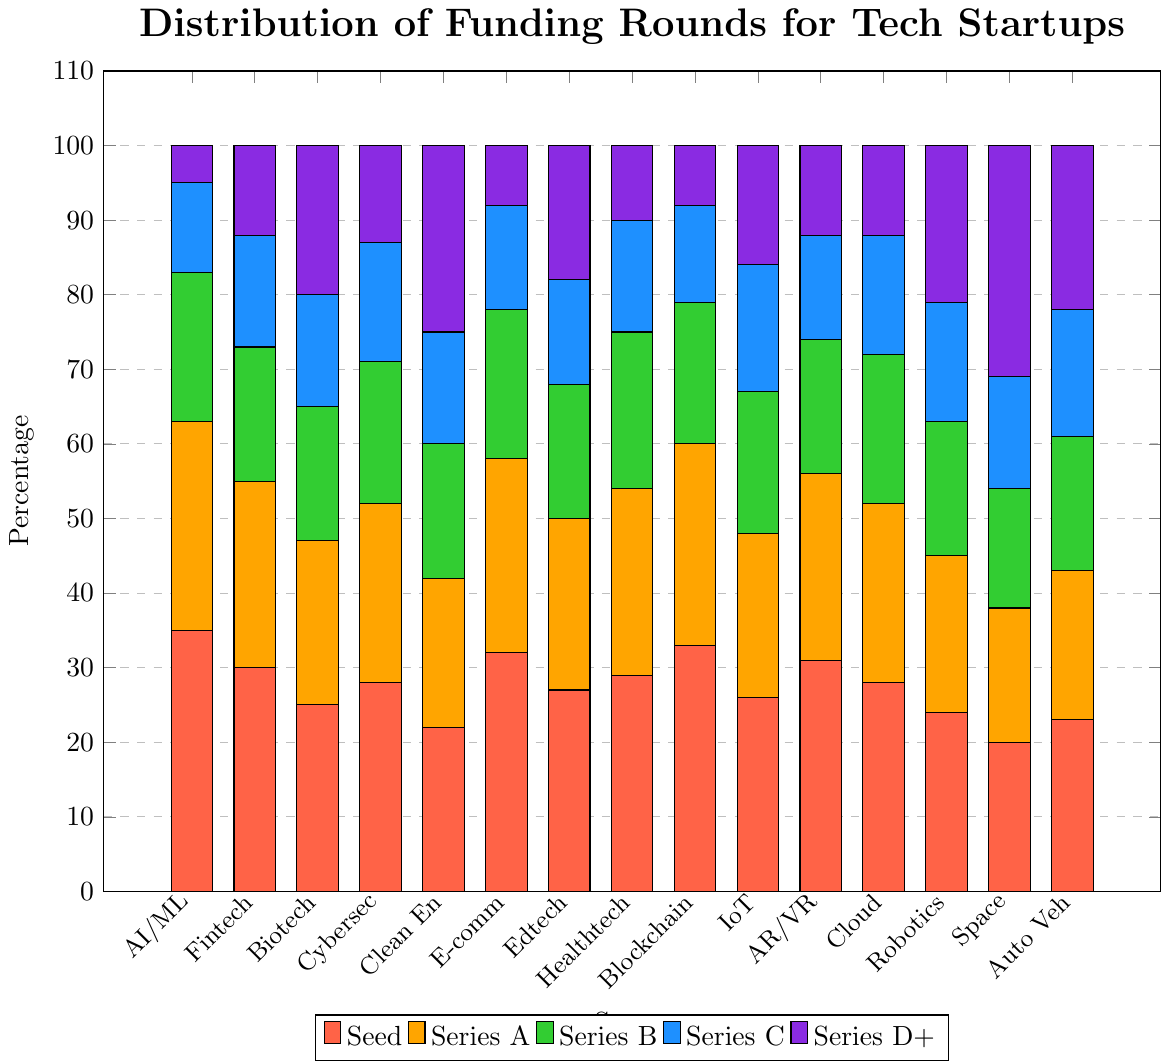Which sector has the highest number of Seed funding rounds? The highest number of Seed funding rounds is indicated by the tallest red bar. By comparing the red bars, AI/Machine Learning has the highest with 35 rounds.
Answer: AI/Machine Learning Which sector has the lowest number of Series D+ funding rounds? The lowest number of Series D+ funding rounds is indicated by the shortest purple bar. By comparing the purple bars, both E-commerce and Blockchain have the lowest with 8 rounds.
Answer: E-commerce, Blockchain How many total funding rounds are there for Biotech across all stages? To find the total, sum the height of the bars for Biotech: 25 (Seed) + 22 (Series A) + 18 (Series B) + 15 (Series C) + 20 (Series D+). The total is 100.
Answer: 100 Which sectors have a higher number of Series C rounds compared to Series B rounds? Compare the heights of the blue (Series C) and green (Series B) bars. For IoT and Autonomous Vehicles, the blue bar (Series C) is higher than the green bar (Series B).
Answer: IoT, Autonomous Vehicles What's the difference in the number of Seed and Series A funding rounds in the Fintech sector? Subtract the number of Series A rounds from the number of Seed rounds for Fintech: 30 (Seed) - 25 (Series A) = 5.
Answer: 5 Which sector has the highest total number of funding rounds? To find the sector with the highest total funding rounds, sum all bars for each sector and compare. AI/Machine Learning has 35 + 28 + 20 + 12 + 5 = 100, and Clean Energy has 22 + 20 + 18 + 15 + 25 = 100. Both sectors have the highest total of 100 rounds.
Answer: AI/Machine Learning, Clean Energy Which sector has more Series A rounds: Healthtech or Edtech? Compare the orange bars for Healthtech and Edtech. Healthtech has 25 rounds, and Edtech has 23 rounds.
Answer: Healthtech Are there any sectors where the number of Series B rounds equals the number of Series C rounds? Compare the green (Series B) and blue (Series C) bars. For Edtech, the numbers are equal at 18 rounds each.
Answer: Edtech 